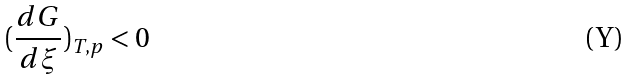Convert formula to latex. <formula><loc_0><loc_0><loc_500><loc_500>( \frac { d G } { d \xi } ) _ { T , p } < 0</formula> 